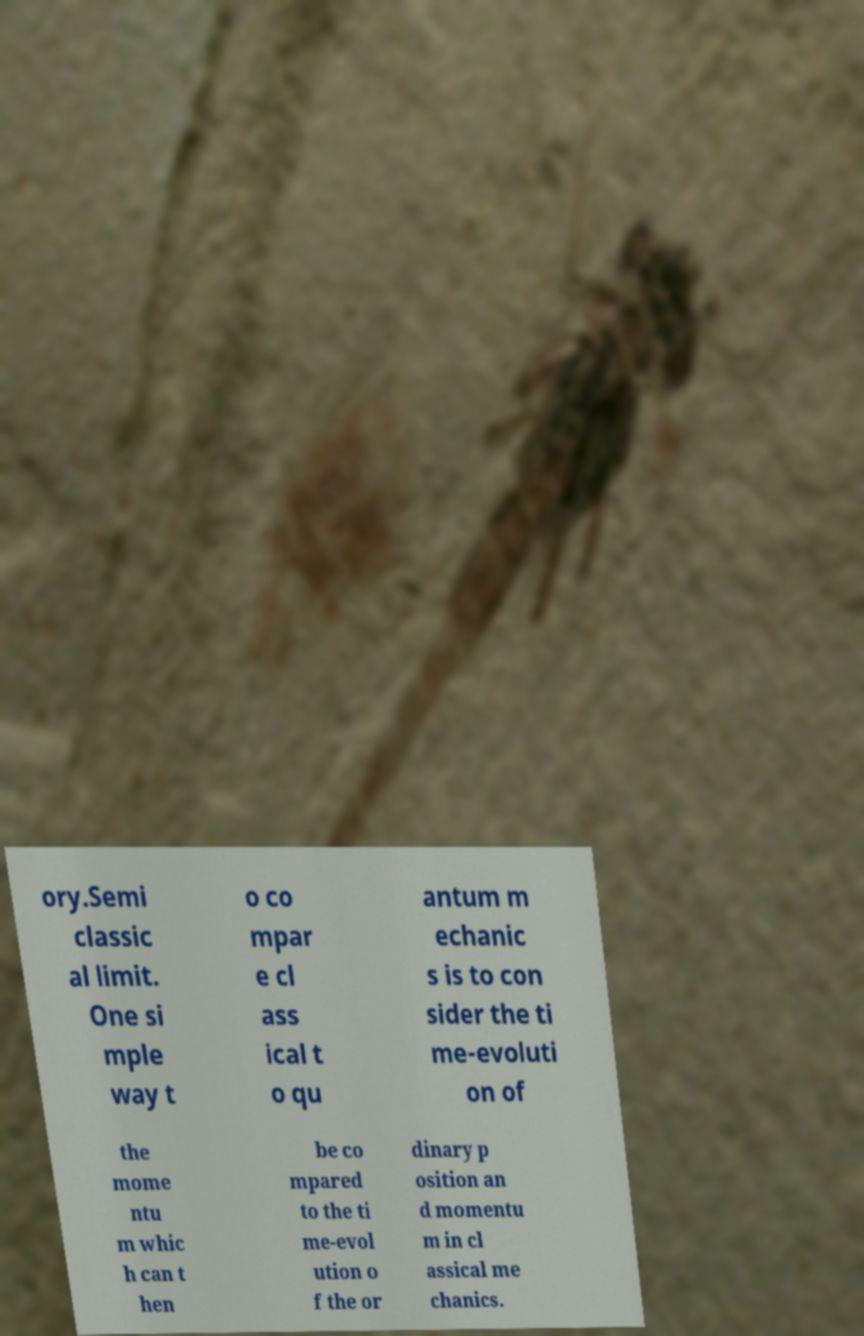Please read and relay the text visible in this image. What does it say? ory.Semi classic al limit. One si mple way t o co mpar e cl ass ical t o qu antum m echanic s is to con sider the ti me-evoluti on of the mome ntu m whic h can t hen be co mpared to the ti me-evol ution o f the or dinary p osition an d momentu m in cl assical me chanics. 